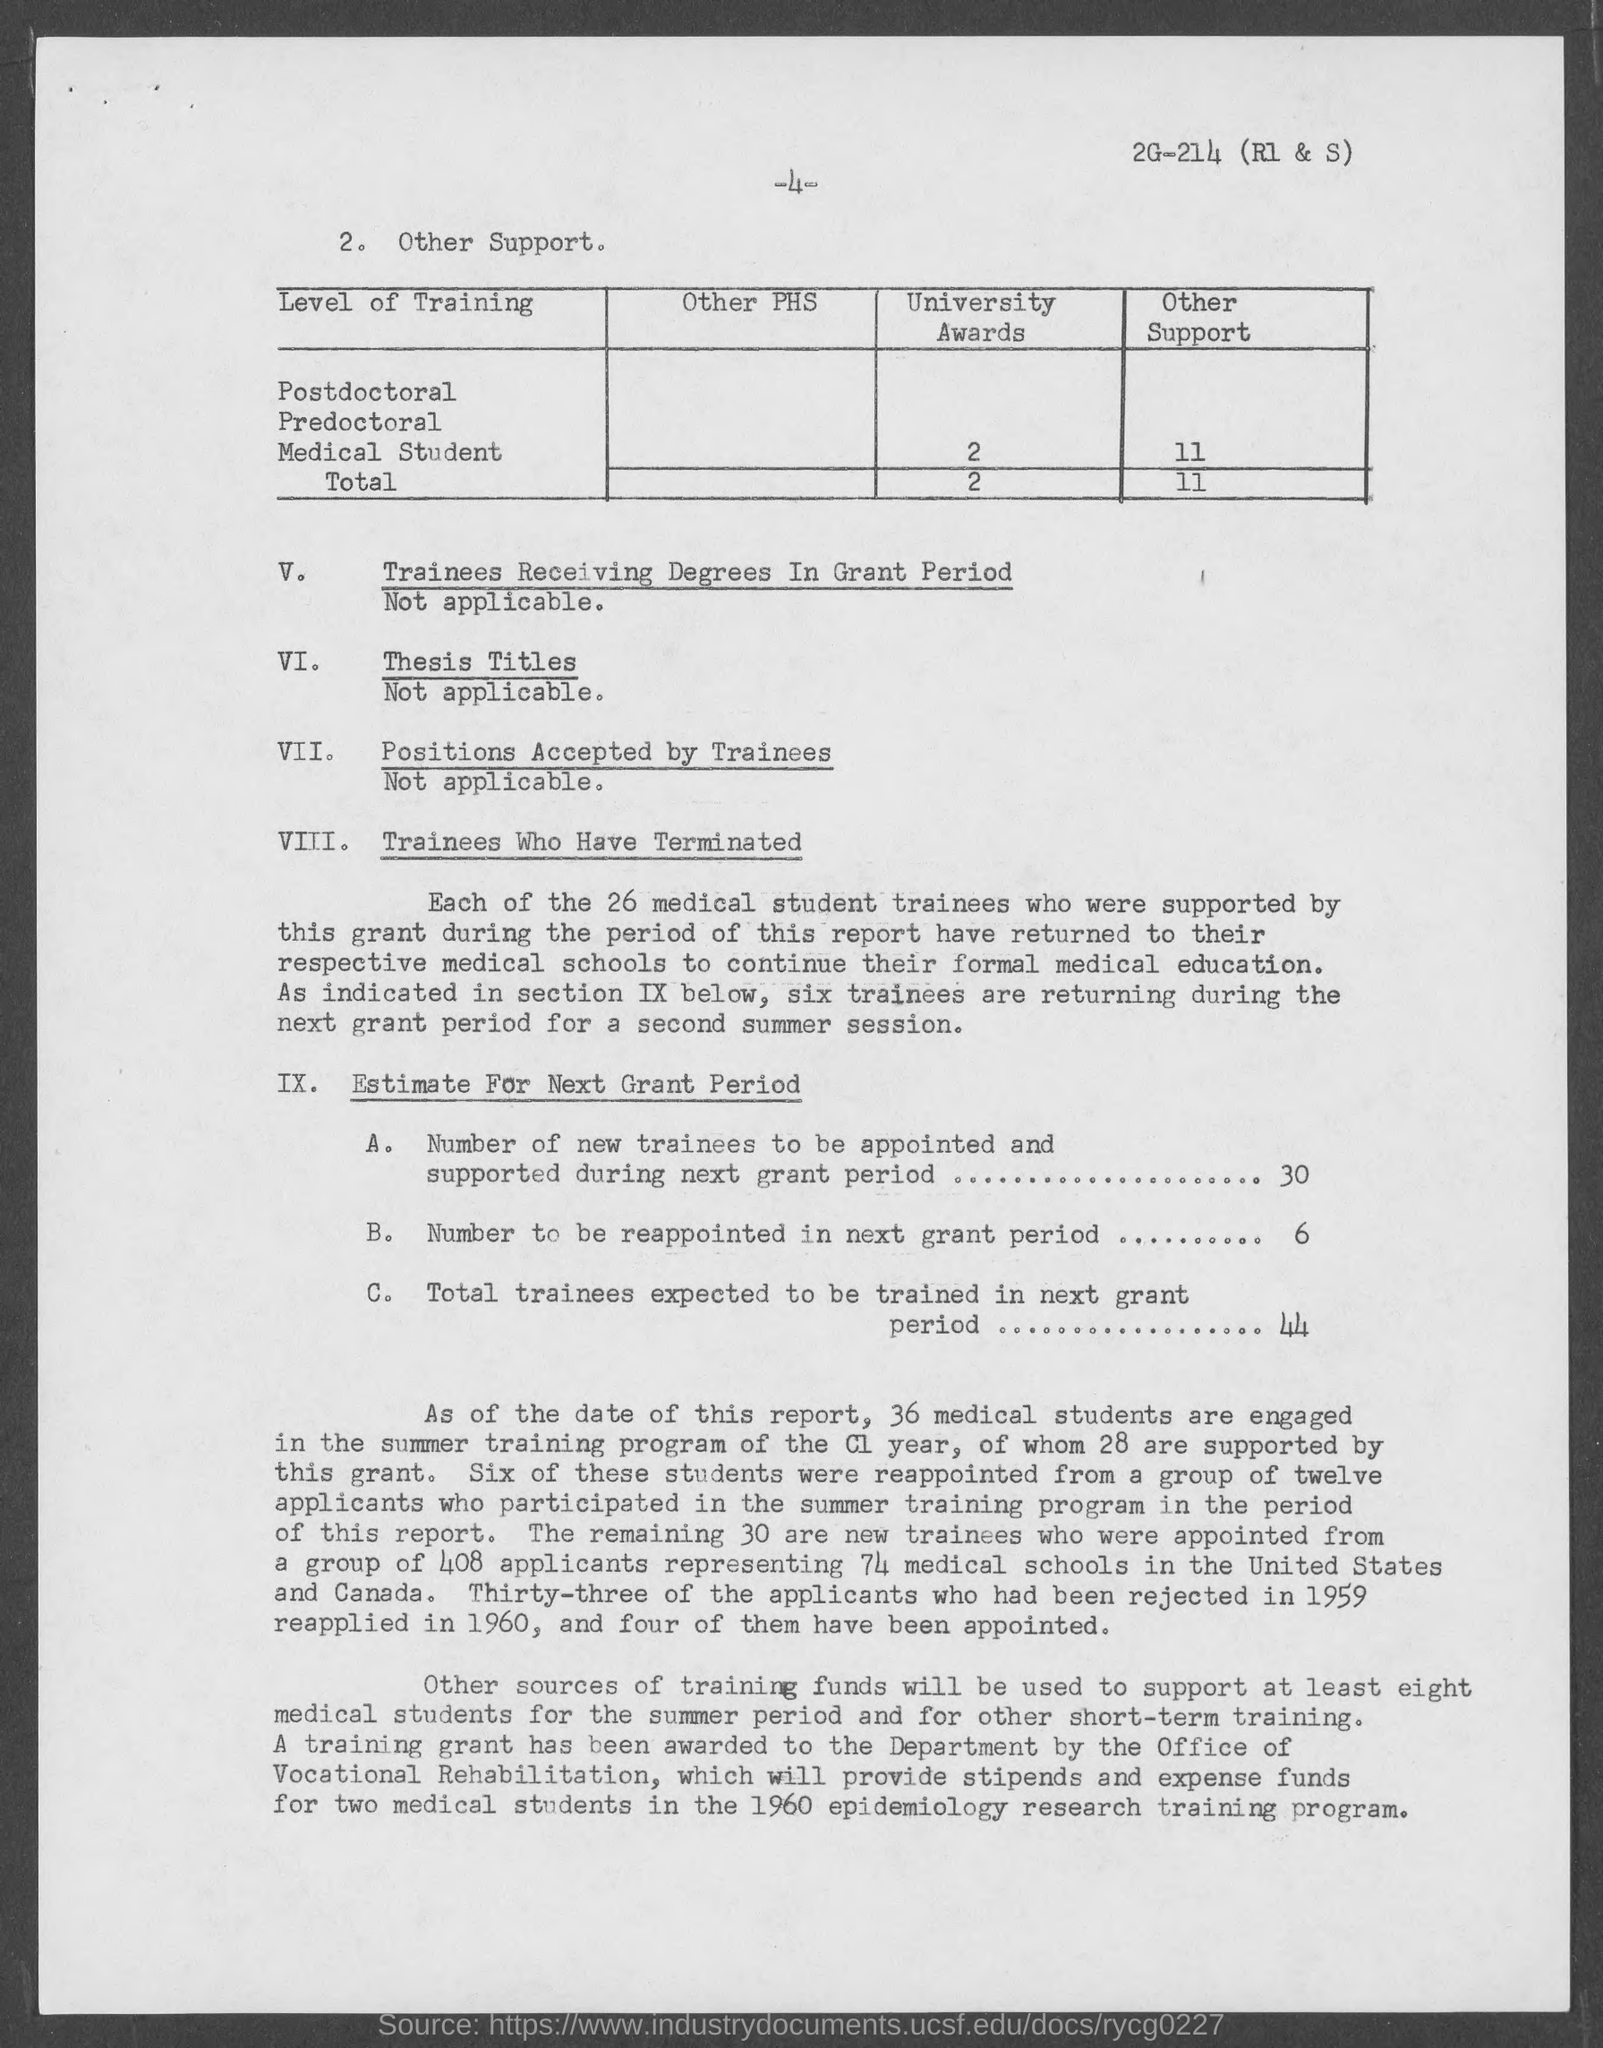Highlight a few significant elements in this photo. The number of individuals who need to be reappointed in the next grant period is 6. The University has awarded a total of 2 University degrees. Thirty new trainees will be appointed and supported for the next grant period. 